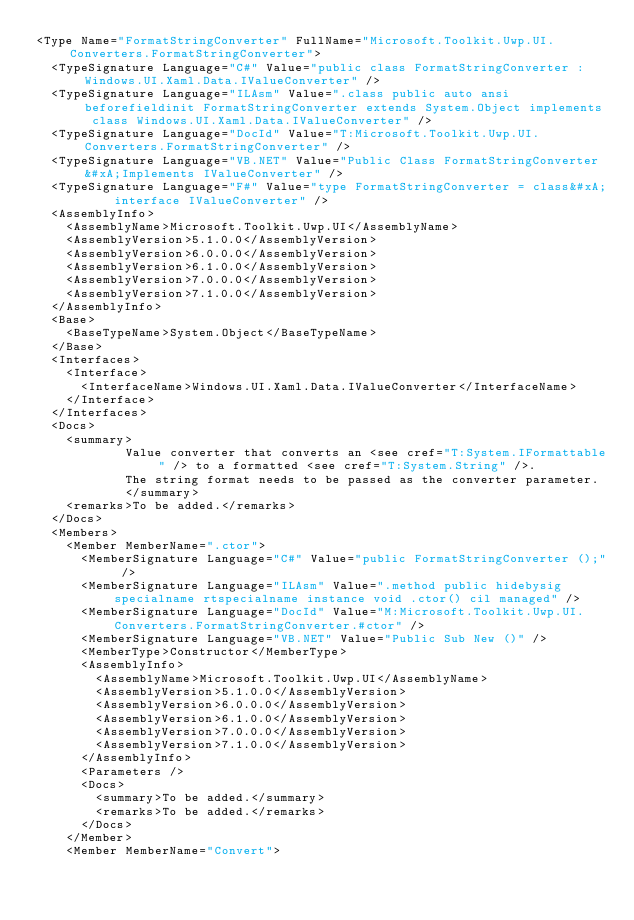<code> <loc_0><loc_0><loc_500><loc_500><_XML_><Type Name="FormatStringConverter" FullName="Microsoft.Toolkit.Uwp.UI.Converters.FormatStringConverter">
  <TypeSignature Language="C#" Value="public class FormatStringConverter : Windows.UI.Xaml.Data.IValueConverter" />
  <TypeSignature Language="ILAsm" Value=".class public auto ansi beforefieldinit FormatStringConverter extends System.Object implements class Windows.UI.Xaml.Data.IValueConverter" />
  <TypeSignature Language="DocId" Value="T:Microsoft.Toolkit.Uwp.UI.Converters.FormatStringConverter" />
  <TypeSignature Language="VB.NET" Value="Public Class FormatStringConverter&#xA;Implements IValueConverter" />
  <TypeSignature Language="F#" Value="type FormatStringConverter = class&#xA;    interface IValueConverter" />
  <AssemblyInfo>
    <AssemblyName>Microsoft.Toolkit.Uwp.UI</AssemblyName>
    <AssemblyVersion>5.1.0.0</AssemblyVersion>
    <AssemblyVersion>6.0.0.0</AssemblyVersion>
    <AssemblyVersion>6.1.0.0</AssemblyVersion>
    <AssemblyVersion>7.0.0.0</AssemblyVersion>
    <AssemblyVersion>7.1.0.0</AssemblyVersion>
  </AssemblyInfo>
  <Base>
    <BaseTypeName>System.Object</BaseTypeName>
  </Base>
  <Interfaces>
    <Interface>
      <InterfaceName>Windows.UI.Xaml.Data.IValueConverter</InterfaceName>
    </Interface>
  </Interfaces>
  <Docs>
    <summary>
            Value converter that converts an <see cref="T:System.IFormattable" /> to a formatted <see cref="T:System.String" />.
            The string format needs to be passed as the converter parameter.
            </summary>
    <remarks>To be added.</remarks>
  </Docs>
  <Members>
    <Member MemberName=".ctor">
      <MemberSignature Language="C#" Value="public FormatStringConverter ();" />
      <MemberSignature Language="ILAsm" Value=".method public hidebysig specialname rtspecialname instance void .ctor() cil managed" />
      <MemberSignature Language="DocId" Value="M:Microsoft.Toolkit.Uwp.UI.Converters.FormatStringConverter.#ctor" />
      <MemberSignature Language="VB.NET" Value="Public Sub New ()" />
      <MemberType>Constructor</MemberType>
      <AssemblyInfo>
        <AssemblyName>Microsoft.Toolkit.Uwp.UI</AssemblyName>
        <AssemblyVersion>5.1.0.0</AssemblyVersion>
        <AssemblyVersion>6.0.0.0</AssemblyVersion>
        <AssemblyVersion>6.1.0.0</AssemblyVersion>
        <AssemblyVersion>7.0.0.0</AssemblyVersion>
        <AssemblyVersion>7.1.0.0</AssemblyVersion>
      </AssemblyInfo>
      <Parameters />
      <Docs>
        <summary>To be added.</summary>
        <remarks>To be added.</remarks>
      </Docs>
    </Member>
    <Member MemberName="Convert"></code> 